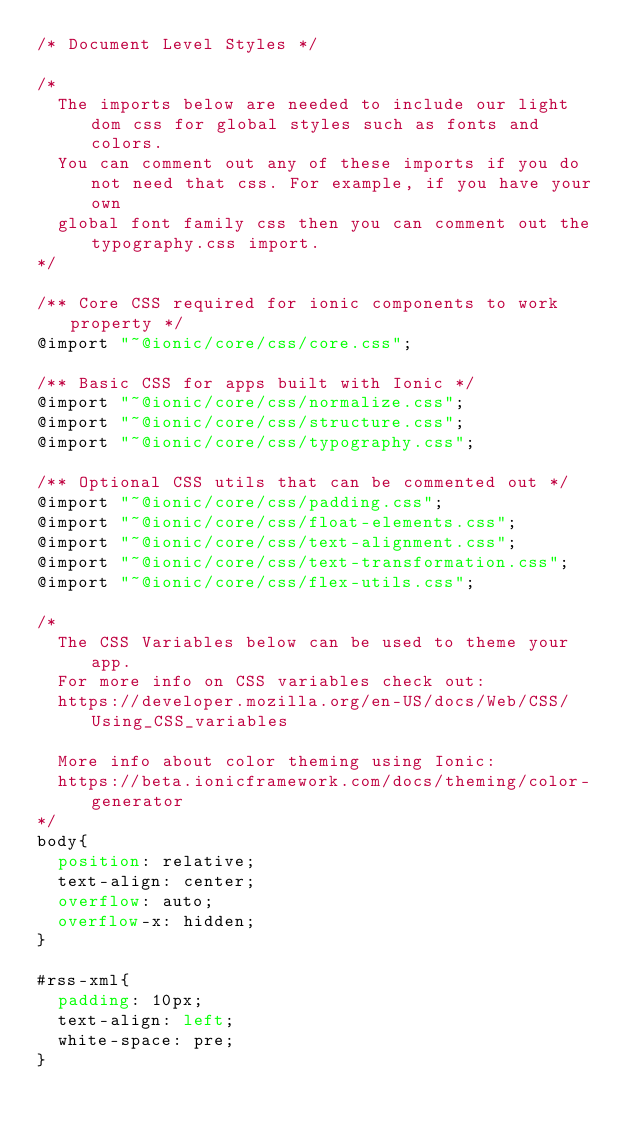<code> <loc_0><loc_0><loc_500><loc_500><_CSS_>/* Document Level Styles */

/*
  The imports below are needed to include our light dom css for global styles such as fonts and colors.
  You can comment out any of these imports if you do not need that css. For example, if you have your own
  global font family css then you can comment out the typography.css import.
*/

/** Core CSS required for ionic components to work property */
@import "~@ionic/core/css/core.css";

/** Basic CSS for apps built with Ionic */
@import "~@ionic/core/css/normalize.css";
@import "~@ionic/core/css/structure.css";
@import "~@ionic/core/css/typography.css";

/** Optional CSS utils that can be commented out */
@import "~@ionic/core/css/padding.css";
@import "~@ionic/core/css/float-elements.css";
@import "~@ionic/core/css/text-alignment.css";
@import "~@ionic/core/css/text-transformation.css";
@import "~@ionic/core/css/flex-utils.css";

/*
  The CSS Variables below can be used to theme your app.
  For more info on CSS variables check out:
  https://developer.mozilla.org/en-US/docs/Web/CSS/Using_CSS_variables

  More info about color theming using Ionic:
  https://beta.ionicframework.com/docs/theming/color-generator
*/
body{
  position: relative;
  text-align: center;
  overflow: auto;
  overflow-x: hidden;
}

#rss-xml{
  padding: 10px;
  text-align: left;
  white-space: pre;
}</code> 